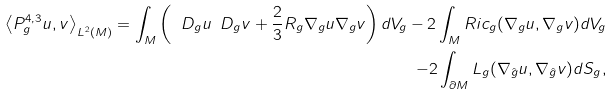Convert formula to latex. <formula><loc_0><loc_0><loc_500><loc_500>\left < P ^ { 4 , 3 } _ { g } u , v \right > _ { L ^ { 2 } ( M ) } = \int _ { M } \left ( \ D _ { g } u \ D _ { g } v + \frac { 2 } { 3 } R _ { g } \nabla _ { g } u \nabla _ { g } v \right ) d V _ { g } - 2 \int _ { M } R i c _ { g } ( \nabla _ { g } u , \nabla _ { g } v ) d V _ { g } \\ - 2 \int _ { \partial M } L _ { g } ( \nabla _ { \hat { g } } u , \nabla _ { \hat { g } } v ) d S _ { g } ,</formula> 